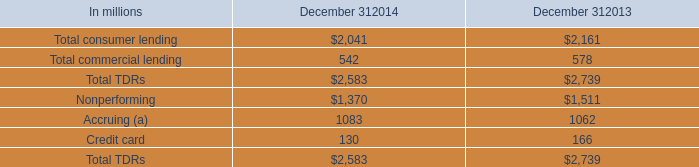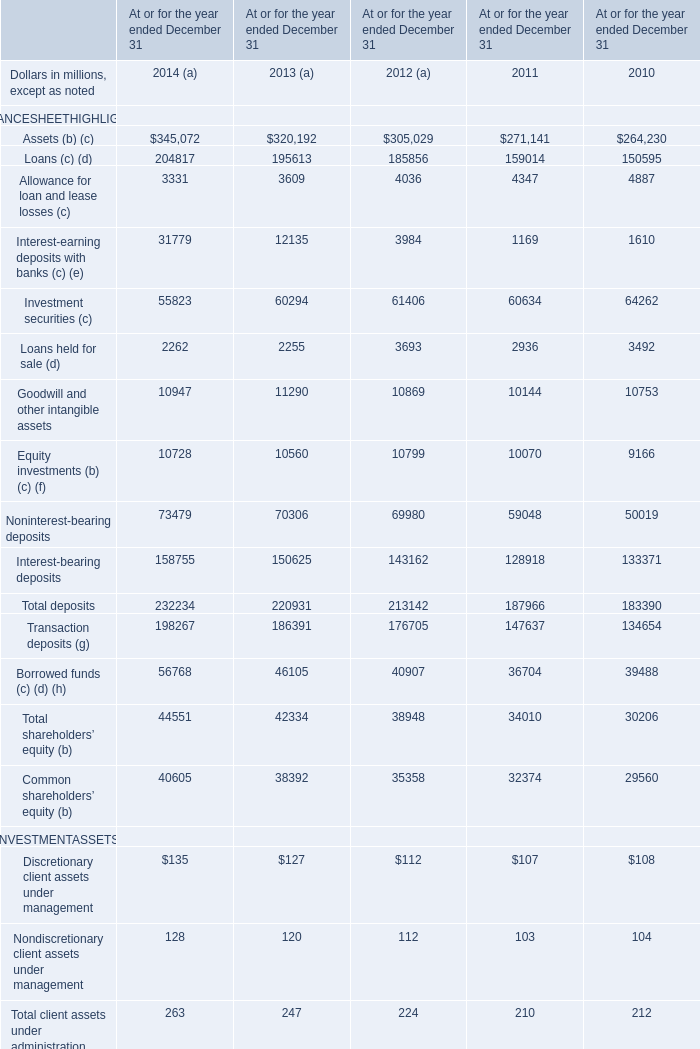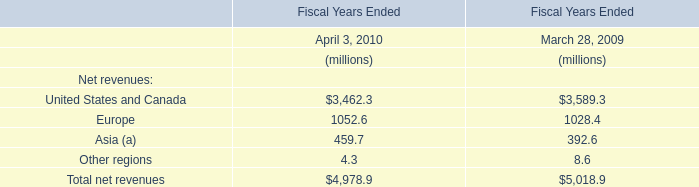what were average specific reserves in the alll in billions at december 31 , 2014 and december 31 , 2013 for the total tdr portfolio? 
Computations: ((.5 + .4) / 2)
Answer: 0.45. 